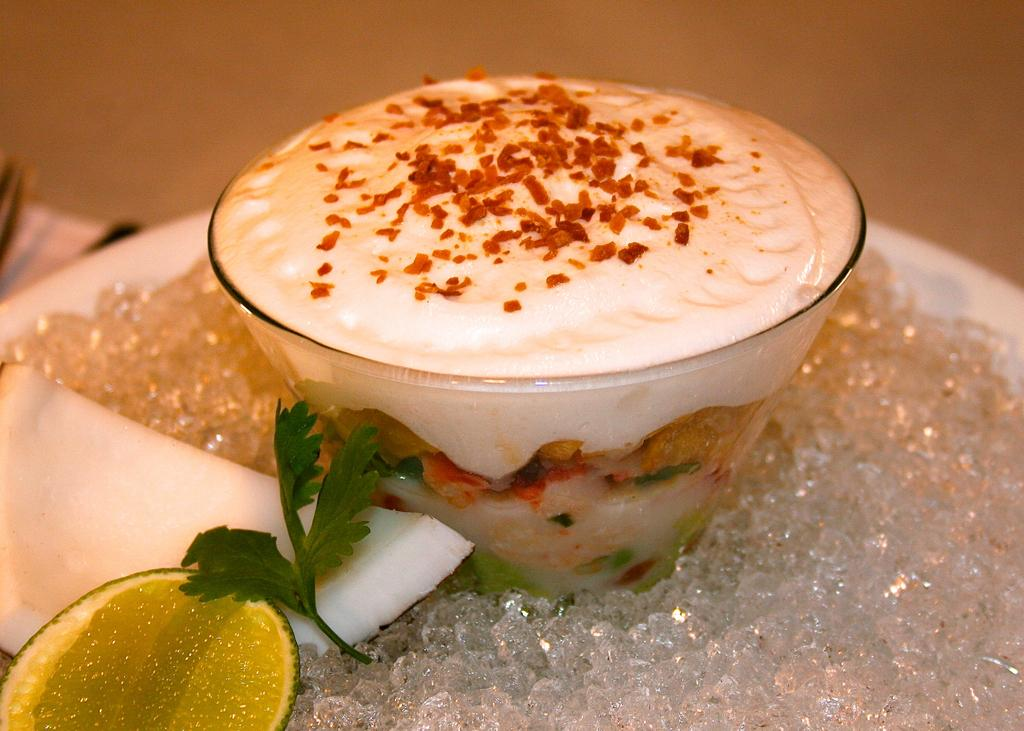What is located at the bottom of the image? There is ice and lemon at the bottom of the image. What can be seen on the left side of the image? There is a piece of coconut on the left side of the image. What type of container is present in the image? There is a cup in the image. What is inside the cup? There is cream in the cup. What type of prose is being recited by the lemon in the image? There is no indication that the lemon is reciting any prose in the image. How many sides does the piece of coconut have in the image? The piece of coconut is a solid object and does not have sides in the traditional sense. 